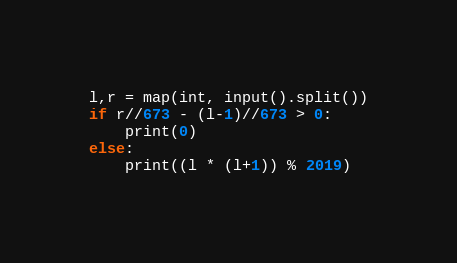<code> <loc_0><loc_0><loc_500><loc_500><_Python_>l,r = map(int, input().split())
if r//673 - (l-1)//673 > 0:
    print(0)
else:
    print((l * (l+1)) % 2019)</code> 